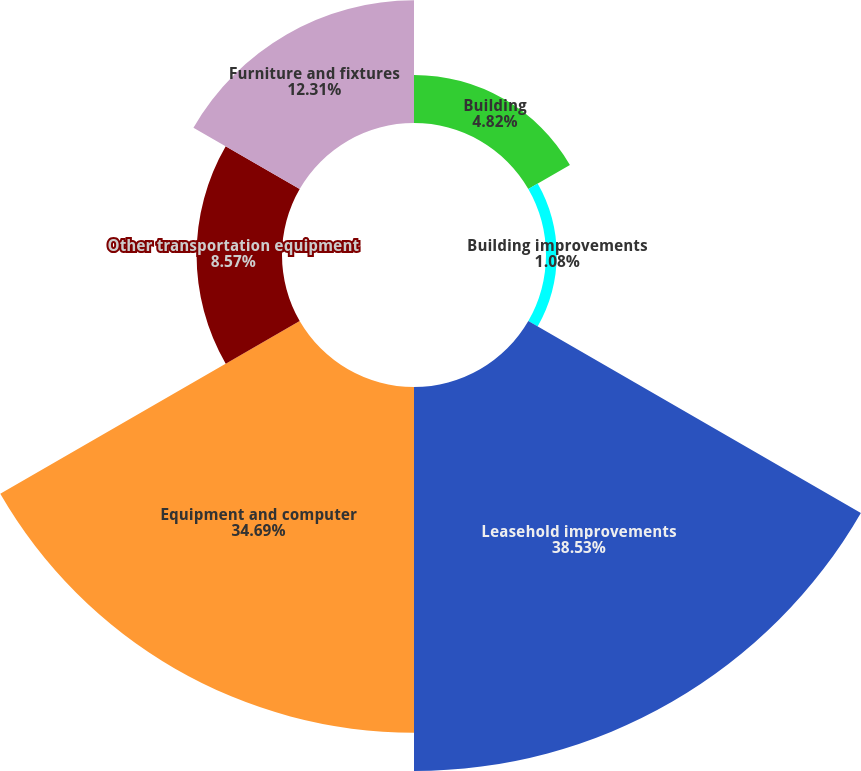<chart> <loc_0><loc_0><loc_500><loc_500><pie_chart><fcel>Building<fcel>Building improvements<fcel>Leasehold improvements<fcel>Equipment and computer<fcel>Other transportation equipment<fcel>Furniture and fixtures<nl><fcel>4.82%<fcel>1.08%<fcel>38.53%<fcel>34.69%<fcel>8.57%<fcel>12.31%<nl></chart> 